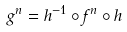Convert formula to latex. <formula><loc_0><loc_0><loc_500><loc_500>g ^ { n } = h ^ { - 1 } \circ f ^ { n } \circ h</formula> 